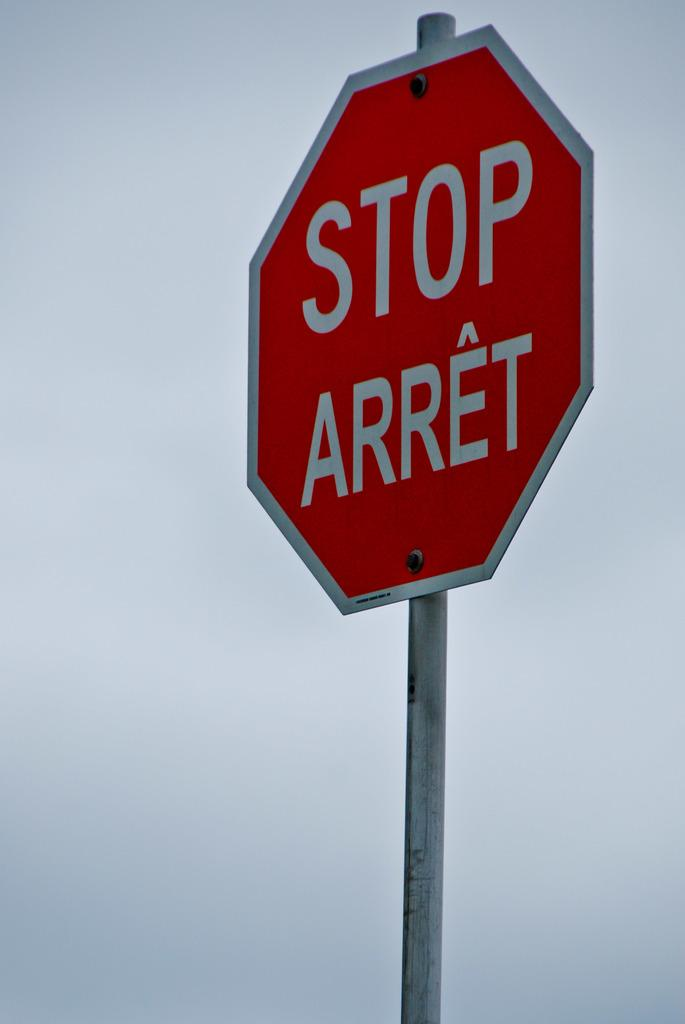<image>
Create a compact narrative representing the image presented. A single stop sign with stop in another language. 